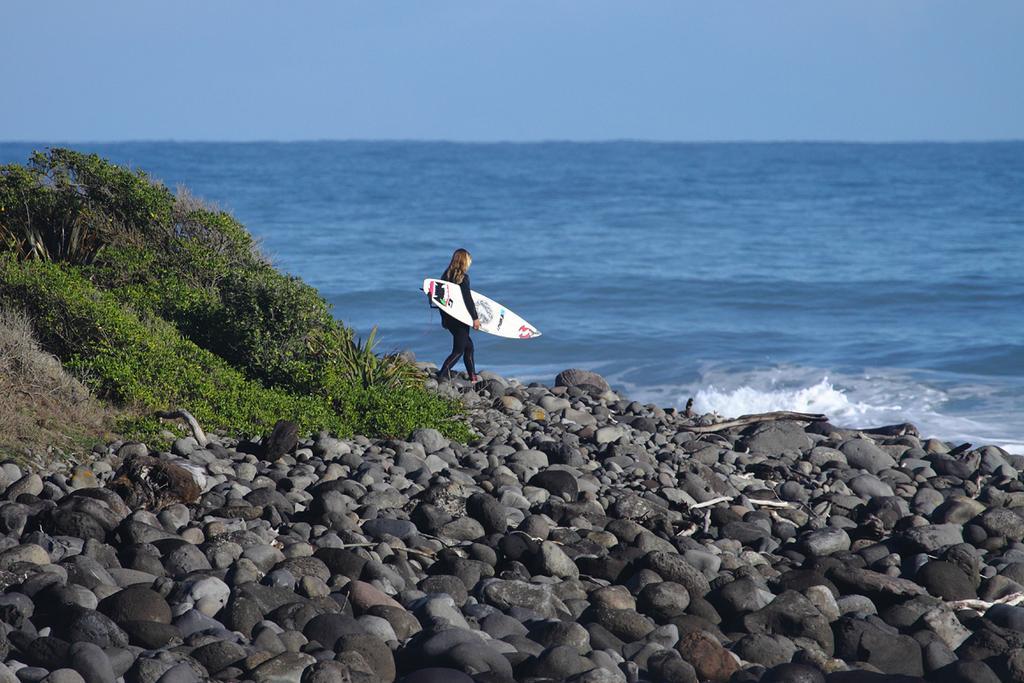How would you summarize this image in a sentence or two? In this picture we can see water and aside to this water we have trees, stones and on the ground woman carrying surfboard with her and above we have sky. 